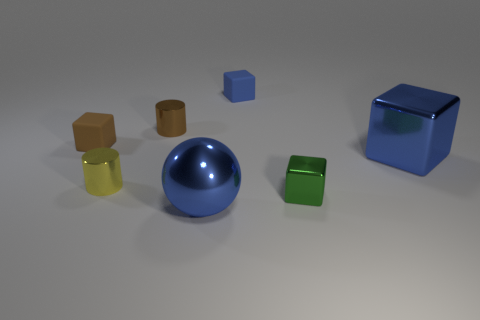Are there fewer large blue metallic spheres right of the metallic ball than big blue blocks in front of the small green object?
Give a very brief answer. No. How many big shiny cubes are there?
Give a very brief answer. 1. There is a green thing that is the same shape as the small blue rubber thing; what is it made of?
Keep it short and to the point. Metal. Are there fewer yellow cylinders that are on the right side of the large blue metallic block than big gray balls?
Your answer should be very brief. No. There is a tiny rubber thing behind the brown cylinder; is its shape the same as the tiny green object?
Make the answer very short. Yes. Is there any other thing of the same color as the small metallic block?
Keep it short and to the point. No. The brown object that is the same material as the big cube is what size?
Keep it short and to the point. Small. What is the material of the blue thing that is behind the block that is to the left of the large blue object in front of the tiny metallic cube?
Make the answer very short. Rubber. Are there fewer tiny blocks than small brown cubes?
Keep it short and to the point. No. Are the big block and the brown cube made of the same material?
Make the answer very short. No. 